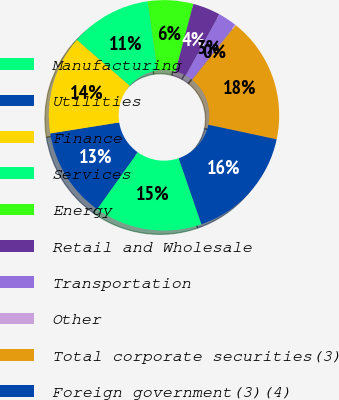<chart> <loc_0><loc_0><loc_500><loc_500><pie_chart><fcel>Manufacturing<fcel>Utilities<fcel>Finance<fcel>Services<fcel>Energy<fcel>Retail and Wholesale<fcel>Transportation<fcel>Other<fcel>Total corporate securities(3)<fcel>Foreign government(3)(4)<nl><fcel>15.13%<fcel>12.63%<fcel>13.88%<fcel>11.38%<fcel>6.37%<fcel>3.87%<fcel>2.62%<fcel>0.12%<fcel>17.63%<fcel>16.38%<nl></chart> 